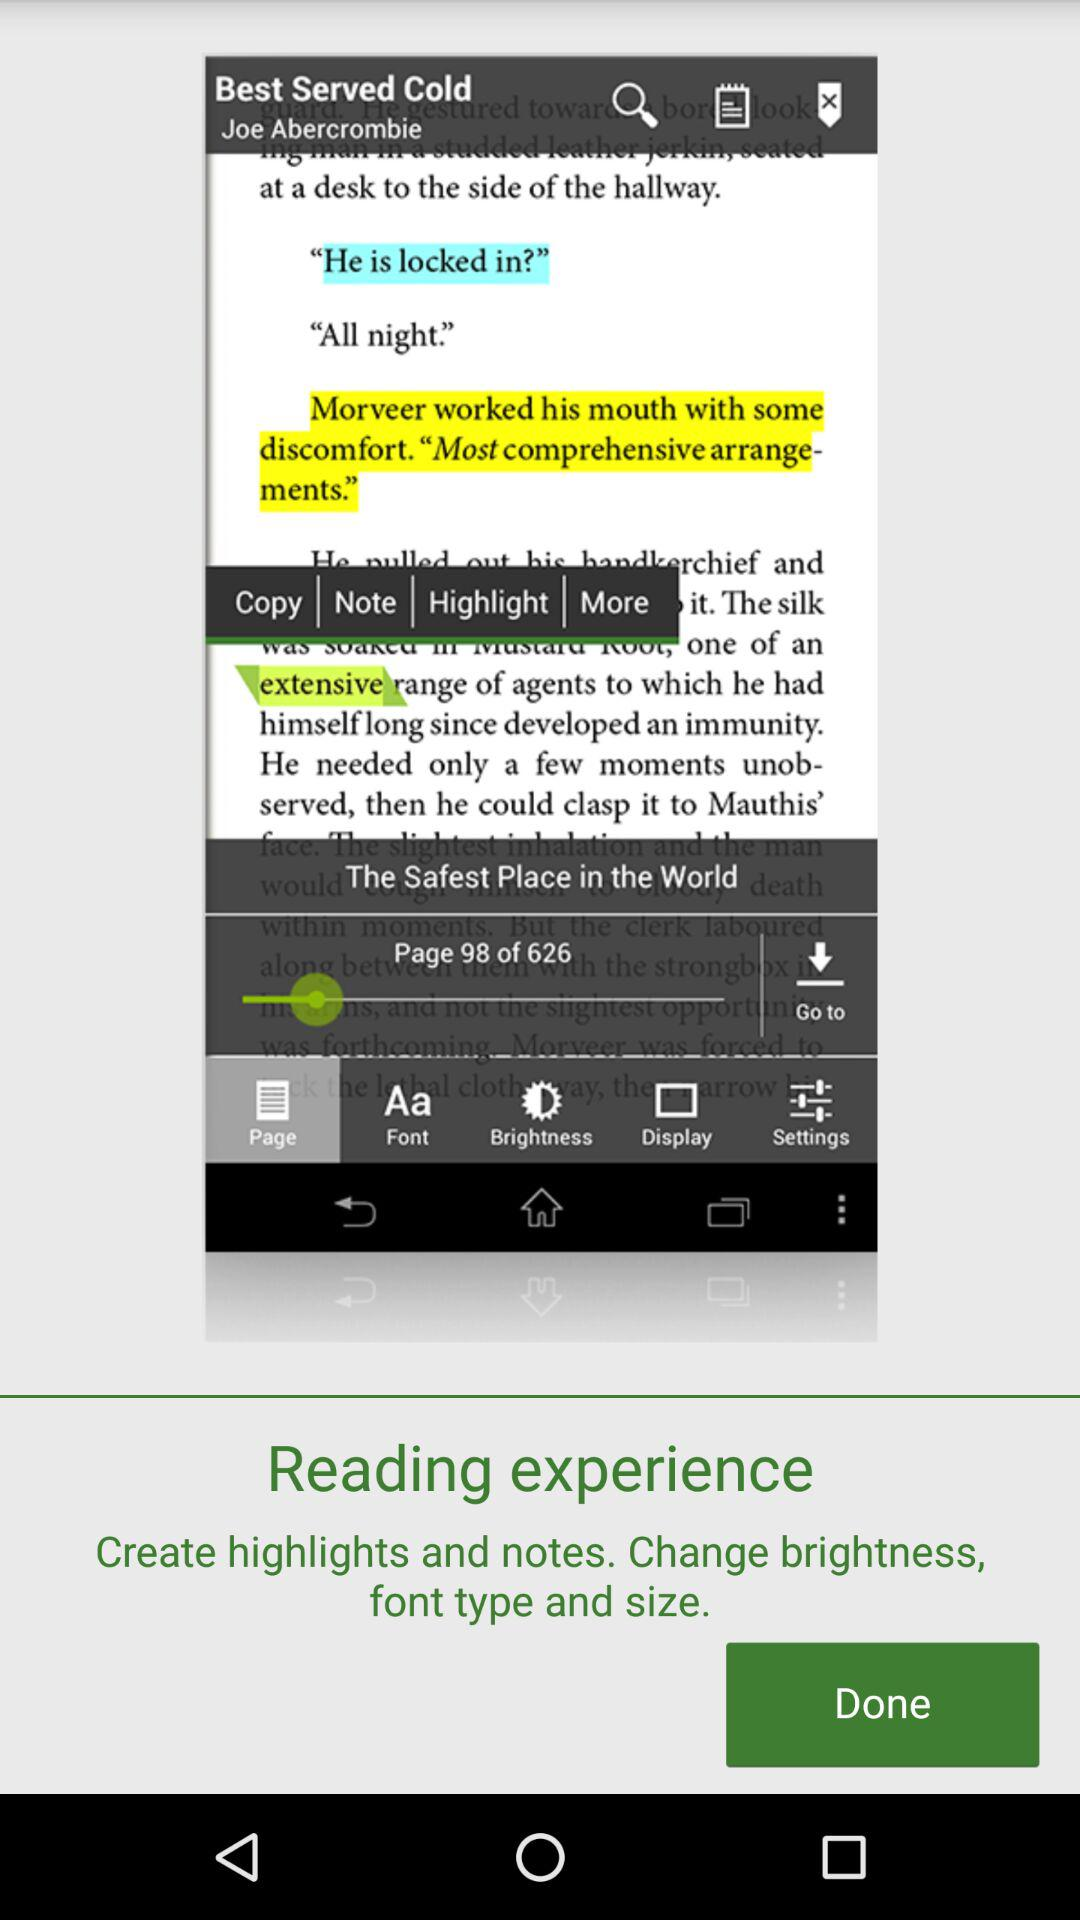What is the current page number? The current page number is 98. 